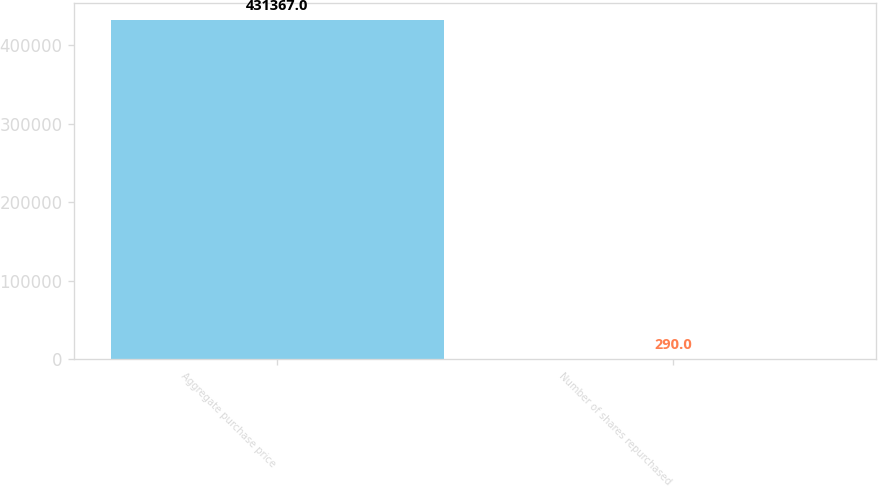<chart> <loc_0><loc_0><loc_500><loc_500><bar_chart><fcel>Aggregate purchase price<fcel>Number of shares repurchased<nl><fcel>431367<fcel>290<nl></chart> 